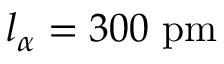Convert formula to latex. <formula><loc_0><loc_0><loc_500><loc_500>l _ { \alpha } = 3 0 0 p m</formula> 